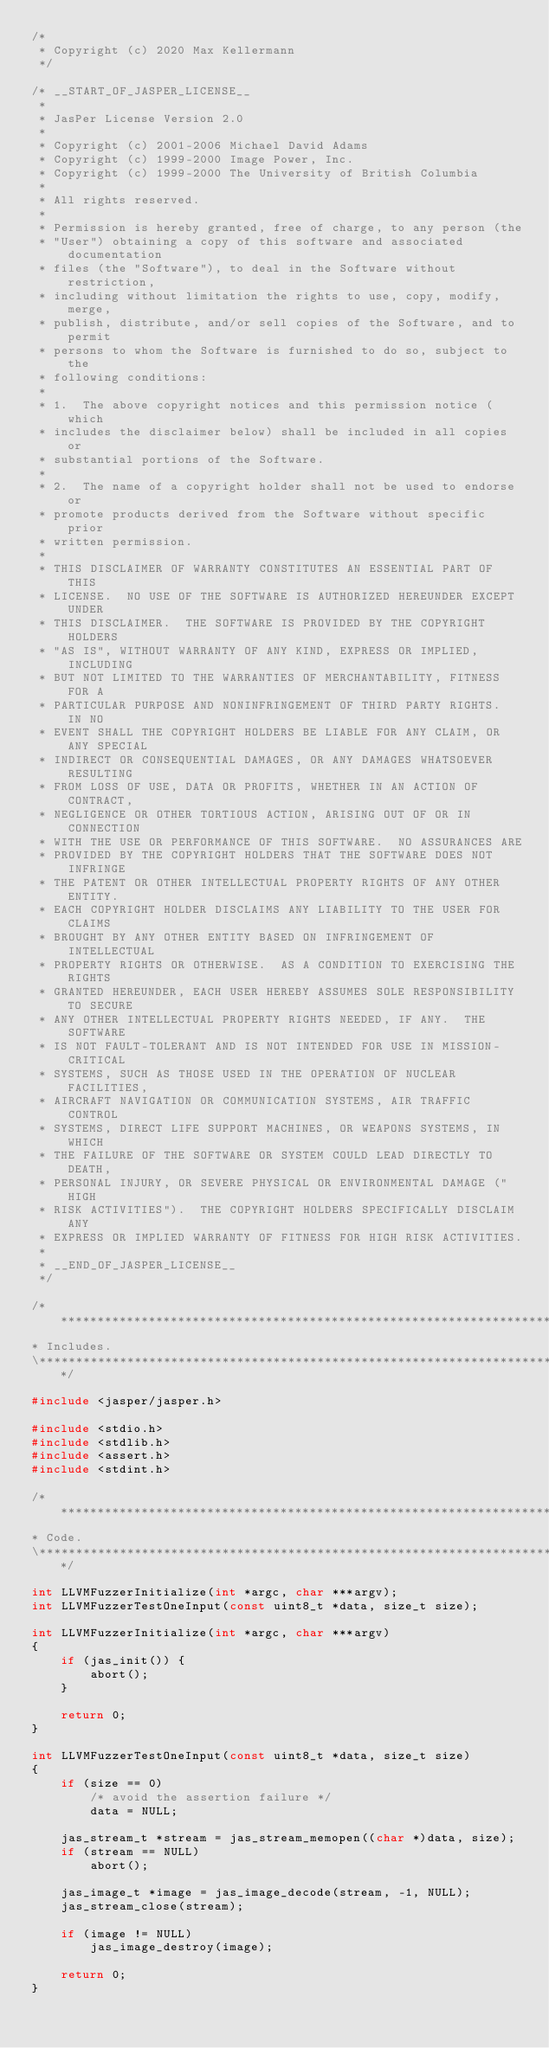<code> <loc_0><loc_0><loc_500><loc_500><_C_>/*
 * Copyright (c) 2020 Max Kellermann
 */

/* __START_OF_JASPER_LICENSE__
 *
 * JasPer License Version 2.0
 *
 * Copyright (c) 2001-2006 Michael David Adams
 * Copyright (c) 1999-2000 Image Power, Inc.
 * Copyright (c) 1999-2000 The University of British Columbia
 *
 * All rights reserved.
 *
 * Permission is hereby granted, free of charge, to any person (the
 * "User") obtaining a copy of this software and associated documentation
 * files (the "Software"), to deal in the Software without restriction,
 * including without limitation the rights to use, copy, modify, merge,
 * publish, distribute, and/or sell copies of the Software, and to permit
 * persons to whom the Software is furnished to do so, subject to the
 * following conditions:
 *
 * 1.  The above copyright notices and this permission notice (which
 * includes the disclaimer below) shall be included in all copies or
 * substantial portions of the Software.
 *
 * 2.  The name of a copyright holder shall not be used to endorse or
 * promote products derived from the Software without specific prior
 * written permission.
 *
 * THIS DISCLAIMER OF WARRANTY CONSTITUTES AN ESSENTIAL PART OF THIS
 * LICENSE.  NO USE OF THE SOFTWARE IS AUTHORIZED HEREUNDER EXCEPT UNDER
 * THIS DISCLAIMER.  THE SOFTWARE IS PROVIDED BY THE COPYRIGHT HOLDERS
 * "AS IS", WITHOUT WARRANTY OF ANY KIND, EXPRESS OR IMPLIED, INCLUDING
 * BUT NOT LIMITED TO THE WARRANTIES OF MERCHANTABILITY, FITNESS FOR A
 * PARTICULAR PURPOSE AND NONINFRINGEMENT OF THIRD PARTY RIGHTS.  IN NO
 * EVENT SHALL THE COPYRIGHT HOLDERS BE LIABLE FOR ANY CLAIM, OR ANY SPECIAL
 * INDIRECT OR CONSEQUENTIAL DAMAGES, OR ANY DAMAGES WHATSOEVER RESULTING
 * FROM LOSS OF USE, DATA OR PROFITS, WHETHER IN AN ACTION OF CONTRACT,
 * NEGLIGENCE OR OTHER TORTIOUS ACTION, ARISING OUT OF OR IN CONNECTION
 * WITH THE USE OR PERFORMANCE OF THIS SOFTWARE.  NO ASSURANCES ARE
 * PROVIDED BY THE COPYRIGHT HOLDERS THAT THE SOFTWARE DOES NOT INFRINGE
 * THE PATENT OR OTHER INTELLECTUAL PROPERTY RIGHTS OF ANY OTHER ENTITY.
 * EACH COPYRIGHT HOLDER DISCLAIMS ANY LIABILITY TO THE USER FOR CLAIMS
 * BROUGHT BY ANY OTHER ENTITY BASED ON INFRINGEMENT OF INTELLECTUAL
 * PROPERTY RIGHTS OR OTHERWISE.  AS A CONDITION TO EXERCISING THE RIGHTS
 * GRANTED HEREUNDER, EACH USER HEREBY ASSUMES SOLE RESPONSIBILITY TO SECURE
 * ANY OTHER INTELLECTUAL PROPERTY RIGHTS NEEDED, IF ANY.  THE SOFTWARE
 * IS NOT FAULT-TOLERANT AND IS NOT INTENDED FOR USE IN MISSION-CRITICAL
 * SYSTEMS, SUCH AS THOSE USED IN THE OPERATION OF NUCLEAR FACILITIES,
 * AIRCRAFT NAVIGATION OR COMMUNICATION SYSTEMS, AIR TRAFFIC CONTROL
 * SYSTEMS, DIRECT LIFE SUPPORT MACHINES, OR WEAPONS SYSTEMS, IN WHICH
 * THE FAILURE OF THE SOFTWARE OR SYSTEM COULD LEAD DIRECTLY TO DEATH,
 * PERSONAL INJURY, OR SEVERE PHYSICAL OR ENVIRONMENTAL DAMAGE ("HIGH
 * RISK ACTIVITIES").  THE COPYRIGHT HOLDERS SPECIFICALLY DISCLAIM ANY
 * EXPRESS OR IMPLIED WARRANTY OF FITNESS FOR HIGH RISK ACTIVITIES.
 *
 * __END_OF_JASPER_LICENSE__
 */

/******************************************************************************\
* Includes.
\******************************************************************************/

#include <jasper/jasper.h>

#include <stdio.h>
#include <stdlib.h>
#include <assert.h>
#include <stdint.h>

/******************************************************************************\
* Code.
\******************************************************************************/

int LLVMFuzzerInitialize(int *argc, char ***argv);
int LLVMFuzzerTestOneInput(const uint8_t *data, size_t size);

int LLVMFuzzerInitialize(int *argc, char ***argv)
{
	if (jas_init()) {
		abort();
	}

	return 0;
}

int LLVMFuzzerTestOneInput(const uint8_t *data, size_t size)
{
	if (size == 0)
		/* avoid the assertion failure */
		data = NULL;

	jas_stream_t *stream = jas_stream_memopen((char *)data, size);
	if (stream == NULL)
		abort();

	jas_image_t *image = jas_image_decode(stream, -1, NULL);
	jas_stream_close(stream);

	if (image != NULL)
		jas_image_destroy(image);

	return 0;
}
</code> 